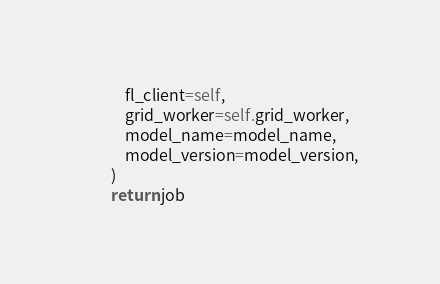<code> <loc_0><loc_0><loc_500><loc_500><_Python_>            fl_client=self,
            grid_worker=self.grid_worker,
            model_name=model_name,
            model_version=model_version,
        )
        return job
</code> 